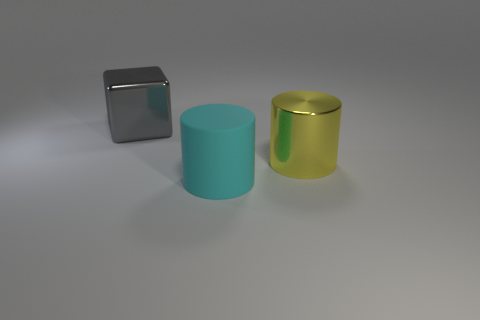Add 1 large metal cubes. How many objects exist? 4 Subtract all blocks. How many objects are left? 2 Add 2 yellow cylinders. How many yellow cylinders exist? 3 Subtract 0 brown blocks. How many objects are left? 3 Subtract all cyan rubber things. Subtract all large shiny blocks. How many objects are left? 1 Add 3 cylinders. How many cylinders are left? 5 